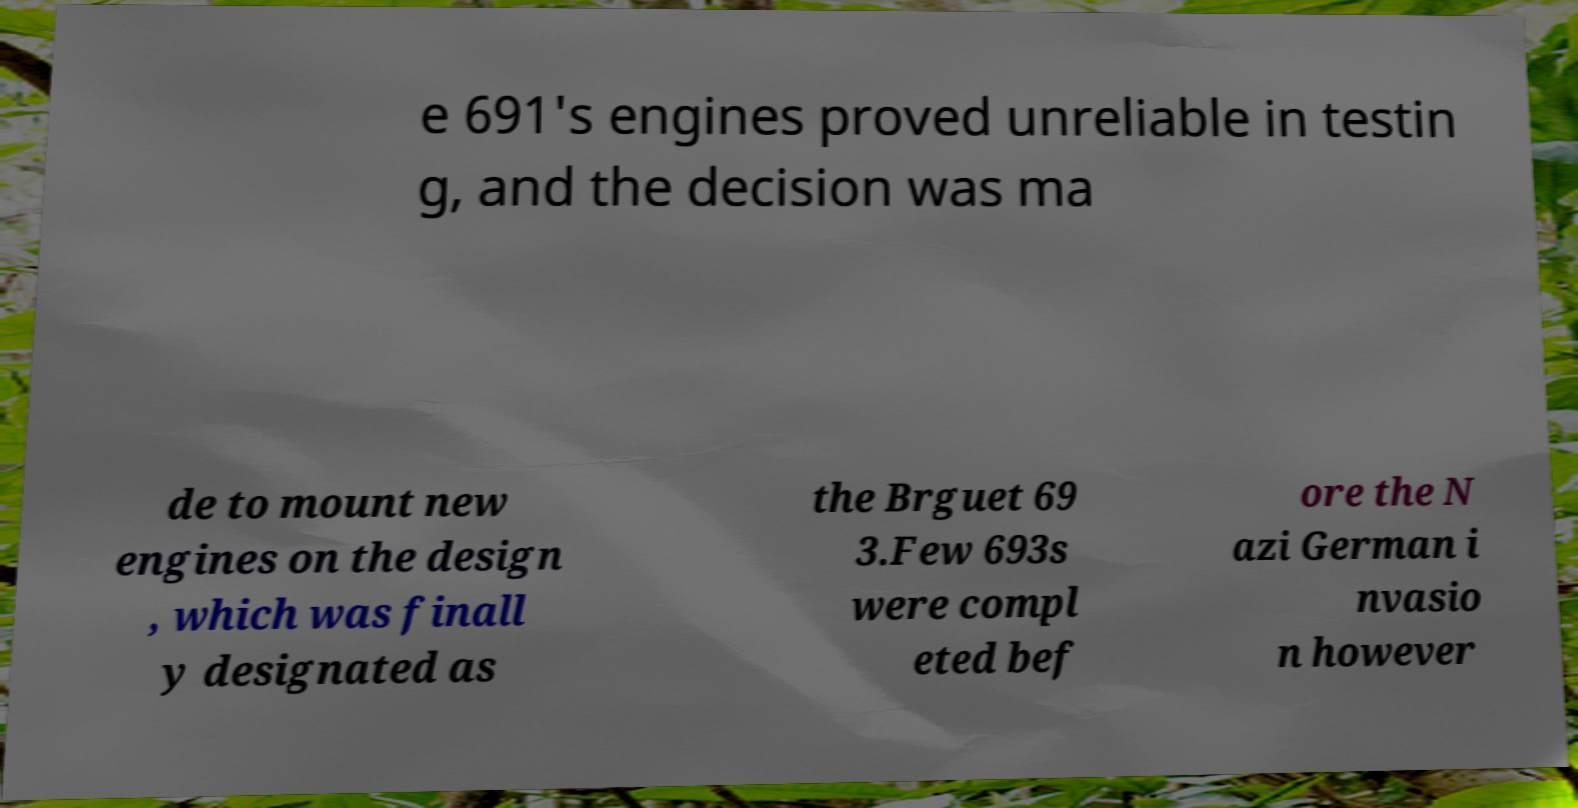I need the written content from this picture converted into text. Can you do that? e 691's engines proved unreliable in testin g, and the decision was ma de to mount new engines on the design , which was finall y designated as the Brguet 69 3.Few 693s were compl eted bef ore the N azi German i nvasio n however 